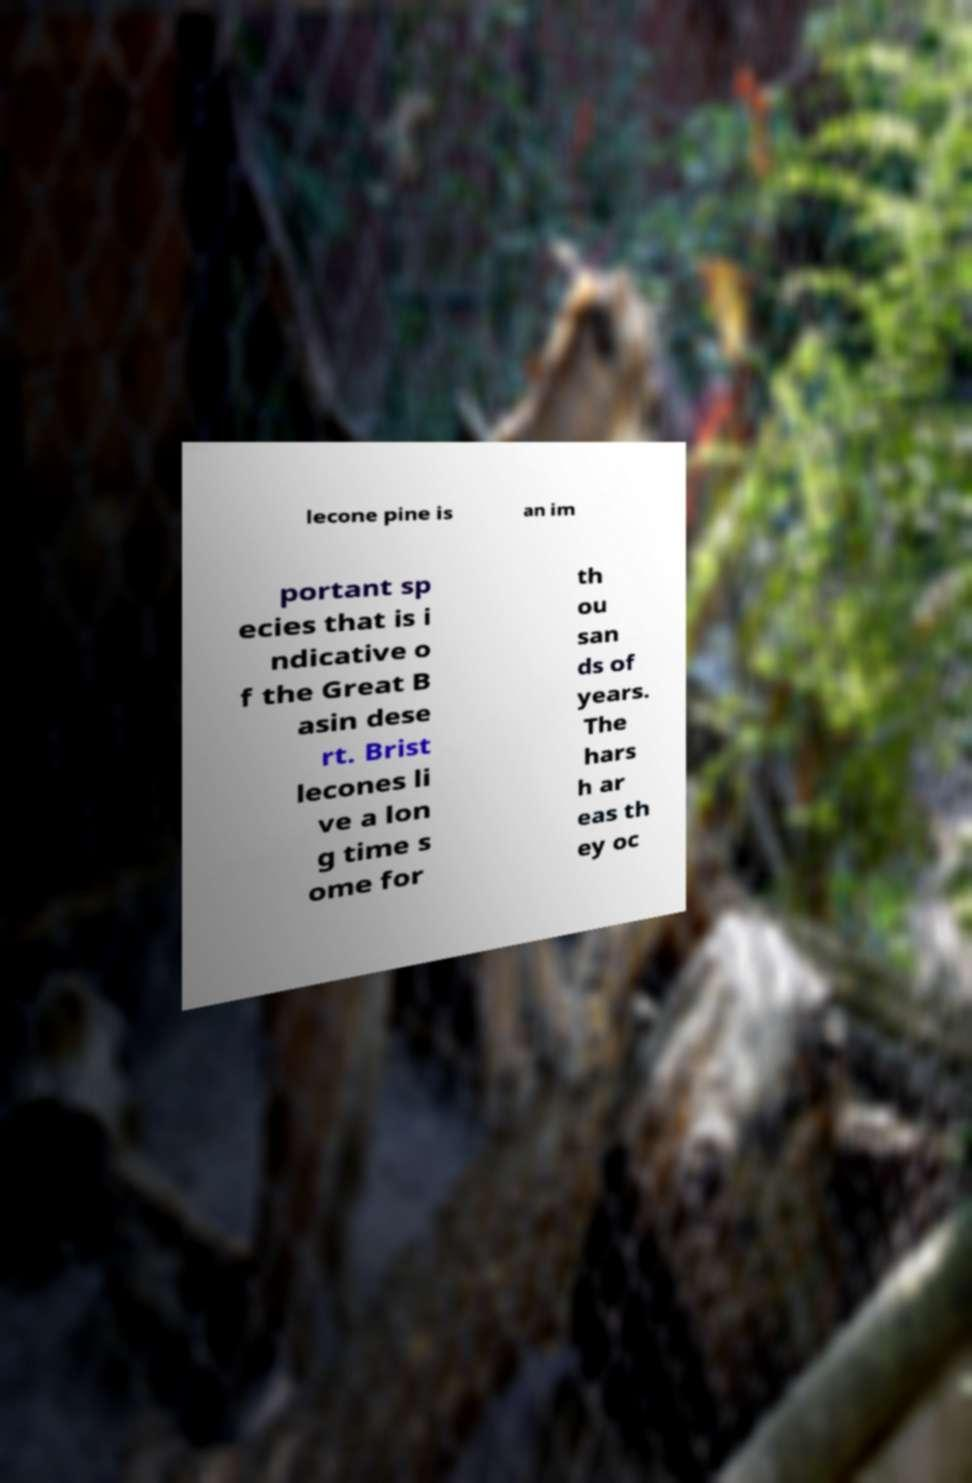Could you assist in decoding the text presented in this image and type it out clearly? lecone pine is an im portant sp ecies that is i ndicative o f the Great B asin dese rt. Brist lecones li ve a lon g time s ome for th ou san ds of years. The hars h ar eas th ey oc 